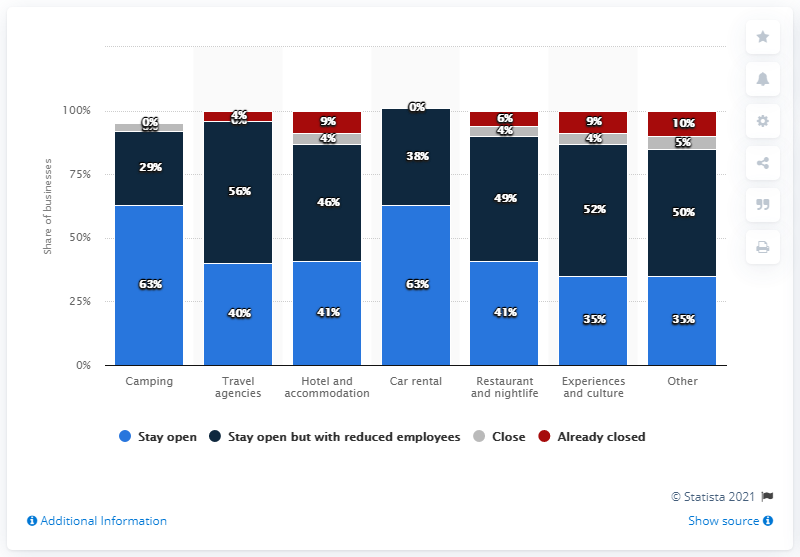Indicate a few pertinent items in this graphic. The average of all the "stay open but with reduced employees" segments is 45.71. 